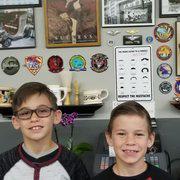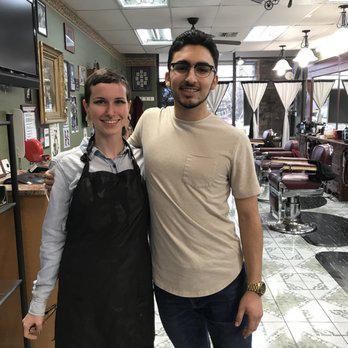The first image is the image on the left, the second image is the image on the right. Evaluate the accuracy of this statement regarding the images: "In at least one image there are two boys side by side in a barber shop.". Is it true? Answer yes or no. Yes. The first image is the image on the left, the second image is the image on the right. Assess this claim about the two images: "An image shows two young boys standing side-by-side and facing forward.". Correct or not? Answer yes or no. Yes. 